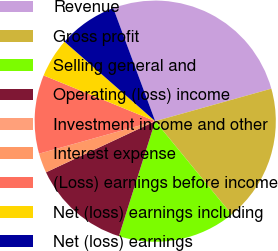Convert chart to OTSL. <chart><loc_0><loc_0><loc_500><loc_500><pie_chart><fcel>Revenue<fcel>Gross profit<fcel>Selling general and<fcel>Operating (loss) income<fcel>Investment income and other<fcel>Interest expense<fcel>(Loss) earnings before income<fcel>Net (loss) earnings including<fcel>Net (loss) earnings<nl><fcel>26.31%<fcel>18.42%<fcel>15.79%<fcel>13.16%<fcel>0.0%<fcel>2.63%<fcel>10.53%<fcel>5.26%<fcel>7.89%<nl></chart> 